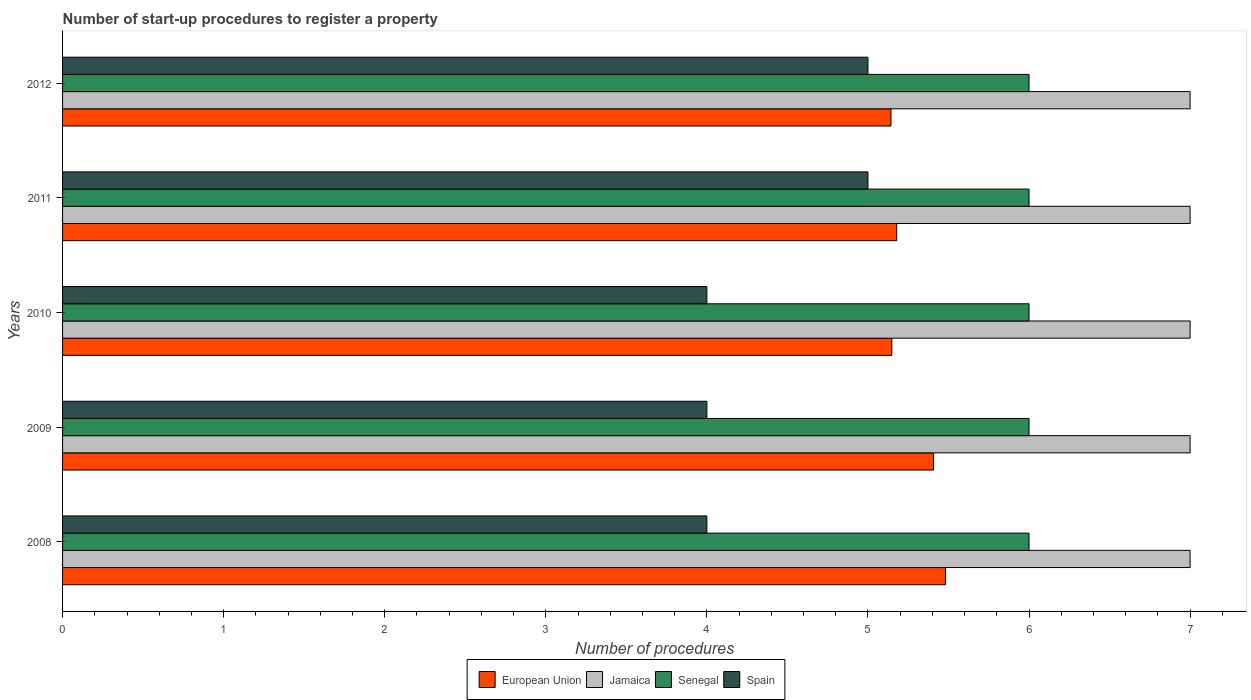How many different coloured bars are there?
Provide a succinct answer. 4. How many groups of bars are there?
Make the answer very short. 5. Are the number of bars on each tick of the Y-axis equal?
Make the answer very short. Yes. How many bars are there on the 2nd tick from the top?
Provide a succinct answer. 4. What is the label of the 2nd group of bars from the top?
Your response must be concise. 2011. In how many cases, is the number of bars for a given year not equal to the number of legend labels?
Make the answer very short. 0. What is the number of procedures required to register a property in Jamaica in 2011?
Offer a terse response. 7. Across all years, what is the maximum number of procedures required to register a property in European Union?
Your answer should be compact. 5.48. Across all years, what is the minimum number of procedures required to register a property in European Union?
Your answer should be compact. 5.14. In which year was the number of procedures required to register a property in Spain minimum?
Keep it short and to the point. 2008. What is the total number of procedures required to register a property in Senegal in the graph?
Provide a short and direct response. 30. What is the difference between the number of procedures required to register a property in Jamaica in 2010 and the number of procedures required to register a property in Spain in 2008?
Provide a short and direct response. 3. In the year 2010, what is the difference between the number of procedures required to register a property in Spain and number of procedures required to register a property in Senegal?
Ensure brevity in your answer.  -2. In how many years, is the number of procedures required to register a property in Spain greater than 1.6 ?
Provide a succinct answer. 5. What is the difference between the highest and the second highest number of procedures required to register a property in European Union?
Offer a terse response. 0.07. What is the difference between the highest and the lowest number of procedures required to register a property in Jamaica?
Offer a very short reply. 0. Is the sum of the number of procedures required to register a property in Spain in 2010 and 2012 greater than the maximum number of procedures required to register a property in European Union across all years?
Give a very brief answer. Yes. What does the 2nd bar from the top in 2011 represents?
Ensure brevity in your answer.  Senegal. What does the 3rd bar from the bottom in 2012 represents?
Offer a terse response. Senegal. Is it the case that in every year, the sum of the number of procedures required to register a property in Jamaica and number of procedures required to register a property in Spain is greater than the number of procedures required to register a property in Senegal?
Make the answer very short. Yes. How many bars are there?
Provide a succinct answer. 20. How many years are there in the graph?
Offer a very short reply. 5. Does the graph contain grids?
Provide a succinct answer. No. Where does the legend appear in the graph?
Offer a very short reply. Bottom center. How many legend labels are there?
Provide a succinct answer. 4. How are the legend labels stacked?
Offer a very short reply. Horizontal. What is the title of the graph?
Your response must be concise. Number of start-up procedures to register a property. Does "Congo (Democratic)" appear as one of the legend labels in the graph?
Provide a succinct answer. No. What is the label or title of the X-axis?
Your response must be concise. Number of procedures. What is the Number of procedures of European Union in 2008?
Offer a terse response. 5.48. What is the Number of procedures of European Union in 2009?
Give a very brief answer. 5.41. What is the Number of procedures of Jamaica in 2009?
Provide a short and direct response. 7. What is the Number of procedures of Senegal in 2009?
Give a very brief answer. 6. What is the Number of procedures in European Union in 2010?
Your response must be concise. 5.15. What is the Number of procedures of Jamaica in 2010?
Your answer should be very brief. 7. What is the Number of procedures in Spain in 2010?
Provide a succinct answer. 4. What is the Number of procedures of European Union in 2011?
Provide a succinct answer. 5.18. What is the Number of procedures of Jamaica in 2011?
Provide a short and direct response. 7. What is the Number of procedures in Senegal in 2011?
Provide a short and direct response. 6. What is the Number of procedures in Spain in 2011?
Make the answer very short. 5. What is the Number of procedures of European Union in 2012?
Offer a very short reply. 5.14. What is the Number of procedures in Jamaica in 2012?
Your response must be concise. 7. What is the Number of procedures in Senegal in 2012?
Keep it short and to the point. 6. Across all years, what is the maximum Number of procedures of European Union?
Your answer should be compact. 5.48. Across all years, what is the maximum Number of procedures of Jamaica?
Keep it short and to the point. 7. Across all years, what is the maximum Number of procedures of Spain?
Your answer should be very brief. 5. Across all years, what is the minimum Number of procedures of European Union?
Ensure brevity in your answer.  5.14. Across all years, what is the minimum Number of procedures in Jamaica?
Keep it short and to the point. 7. Across all years, what is the minimum Number of procedures in Senegal?
Offer a terse response. 6. What is the total Number of procedures in European Union in the graph?
Provide a succinct answer. 26.36. What is the total Number of procedures of Senegal in the graph?
Provide a short and direct response. 30. What is the difference between the Number of procedures in European Union in 2008 and that in 2009?
Your answer should be very brief. 0.07. What is the difference between the Number of procedures in Spain in 2008 and that in 2009?
Provide a short and direct response. 0. What is the difference between the Number of procedures of European Union in 2008 and that in 2010?
Make the answer very short. 0.33. What is the difference between the Number of procedures of Senegal in 2008 and that in 2010?
Keep it short and to the point. 0. What is the difference between the Number of procedures in Spain in 2008 and that in 2010?
Offer a terse response. 0. What is the difference between the Number of procedures in European Union in 2008 and that in 2011?
Offer a very short reply. 0.3. What is the difference between the Number of procedures in Senegal in 2008 and that in 2011?
Keep it short and to the point. 0. What is the difference between the Number of procedures in European Union in 2008 and that in 2012?
Your answer should be compact. 0.34. What is the difference between the Number of procedures of Jamaica in 2008 and that in 2012?
Provide a short and direct response. 0. What is the difference between the Number of procedures in European Union in 2009 and that in 2010?
Offer a very short reply. 0.26. What is the difference between the Number of procedures in European Union in 2009 and that in 2011?
Provide a succinct answer. 0.23. What is the difference between the Number of procedures in European Union in 2009 and that in 2012?
Your answer should be compact. 0.26. What is the difference between the Number of procedures of European Union in 2010 and that in 2011?
Provide a succinct answer. -0.03. What is the difference between the Number of procedures in Senegal in 2010 and that in 2011?
Your answer should be very brief. 0. What is the difference between the Number of procedures of European Union in 2010 and that in 2012?
Ensure brevity in your answer.  0.01. What is the difference between the Number of procedures in Spain in 2010 and that in 2012?
Your answer should be very brief. -1. What is the difference between the Number of procedures in European Union in 2011 and that in 2012?
Provide a succinct answer. 0.04. What is the difference between the Number of procedures of Senegal in 2011 and that in 2012?
Offer a terse response. 0. What is the difference between the Number of procedures in European Union in 2008 and the Number of procedures in Jamaica in 2009?
Your answer should be compact. -1.52. What is the difference between the Number of procedures in European Union in 2008 and the Number of procedures in Senegal in 2009?
Offer a terse response. -0.52. What is the difference between the Number of procedures in European Union in 2008 and the Number of procedures in Spain in 2009?
Your answer should be compact. 1.48. What is the difference between the Number of procedures in Jamaica in 2008 and the Number of procedures in Senegal in 2009?
Make the answer very short. 1. What is the difference between the Number of procedures in Jamaica in 2008 and the Number of procedures in Spain in 2009?
Your answer should be very brief. 3. What is the difference between the Number of procedures in European Union in 2008 and the Number of procedures in Jamaica in 2010?
Make the answer very short. -1.52. What is the difference between the Number of procedures in European Union in 2008 and the Number of procedures in Senegal in 2010?
Your response must be concise. -0.52. What is the difference between the Number of procedures in European Union in 2008 and the Number of procedures in Spain in 2010?
Keep it short and to the point. 1.48. What is the difference between the Number of procedures in European Union in 2008 and the Number of procedures in Jamaica in 2011?
Your response must be concise. -1.52. What is the difference between the Number of procedures in European Union in 2008 and the Number of procedures in Senegal in 2011?
Your answer should be compact. -0.52. What is the difference between the Number of procedures of European Union in 2008 and the Number of procedures of Spain in 2011?
Your answer should be very brief. 0.48. What is the difference between the Number of procedures in Jamaica in 2008 and the Number of procedures in Senegal in 2011?
Give a very brief answer. 1. What is the difference between the Number of procedures of Jamaica in 2008 and the Number of procedures of Spain in 2011?
Provide a short and direct response. 2. What is the difference between the Number of procedures in European Union in 2008 and the Number of procedures in Jamaica in 2012?
Provide a succinct answer. -1.52. What is the difference between the Number of procedures of European Union in 2008 and the Number of procedures of Senegal in 2012?
Offer a terse response. -0.52. What is the difference between the Number of procedures of European Union in 2008 and the Number of procedures of Spain in 2012?
Ensure brevity in your answer.  0.48. What is the difference between the Number of procedures of Jamaica in 2008 and the Number of procedures of Senegal in 2012?
Provide a succinct answer. 1. What is the difference between the Number of procedures in European Union in 2009 and the Number of procedures in Jamaica in 2010?
Give a very brief answer. -1.59. What is the difference between the Number of procedures of European Union in 2009 and the Number of procedures of Senegal in 2010?
Your response must be concise. -0.59. What is the difference between the Number of procedures in European Union in 2009 and the Number of procedures in Spain in 2010?
Give a very brief answer. 1.41. What is the difference between the Number of procedures in Jamaica in 2009 and the Number of procedures in Senegal in 2010?
Offer a terse response. 1. What is the difference between the Number of procedures in Jamaica in 2009 and the Number of procedures in Spain in 2010?
Your response must be concise. 3. What is the difference between the Number of procedures of European Union in 2009 and the Number of procedures of Jamaica in 2011?
Make the answer very short. -1.59. What is the difference between the Number of procedures of European Union in 2009 and the Number of procedures of Senegal in 2011?
Give a very brief answer. -0.59. What is the difference between the Number of procedures in European Union in 2009 and the Number of procedures in Spain in 2011?
Your answer should be very brief. 0.41. What is the difference between the Number of procedures in Jamaica in 2009 and the Number of procedures in Spain in 2011?
Your answer should be very brief. 2. What is the difference between the Number of procedures of European Union in 2009 and the Number of procedures of Jamaica in 2012?
Provide a short and direct response. -1.59. What is the difference between the Number of procedures of European Union in 2009 and the Number of procedures of Senegal in 2012?
Offer a very short reply. -0.59. What is the difference between the Number of procedures in European Union in 2009 and the Number of procedures in Spain in 2012?
Offer a terse response. 0.41. What is the difference between the Number of procedures in Jamaica in 2009 and the Number of procedures in Senegal in 2012?
Provide a short and direct response. 1. What is the difference between the Number of procedures in Senegal in 2009 and the Number of procedures in Spain in 2012?
Offer a very short reply. 1. What is the difference between the Number of procedures in European Union in 2010 and the Number of procedures in Jamaica in 2011?
Your response must be concise. -1.85. What is the difference between the Number of procedures in European Union in 2010 and the Number of procedures in Senegal in 2011?
Ensure brevity in your answer.  -0.85. What is the difference between the Number of procedures in European Union in 2010 and the Number of procedures in Spain in 2011?
Make the answer very short. 0.15. What is the difference between the Number of procedures of Jamaica in 2010 and the Number of procedures of Senegal in 2011?
Your response must be concise. 1. What is the difference between the Number of procedures of Jamaica in 2010 and the Number of procedures of Spain in 2011?
Offer a very short reply. 2. What is the difference between the Number of procedures of Senegal in 2010 and the Number of procedures of Spain in 2011?
Provide a succinct answer. 1. What is the difference between the Number of procedures in European Union in 2010 and the Number of procedures in Jamaica in 2012?
Provide a short and direct response. -1.85. What is the difference between the Number of procedures in European Union in 2010 and the Number of procedures in Senegal in 2012?
Your answer should be very brief. -0.85. What is the difference between the Number of procedures of European Union in 2010 and the Number of procedures of Spain in 2012?
Keep it short and to the point. 0.15. What is the difference between the Number of procedures in Jamaica in 2010 and the Number of procedures in Spain in 2012?
Give a very brief answer. 2. What is the difference between the Number of procedures of Senegal in 2010 and the Number of procedures of Spain in 2012?
Offer a terse response. 1. What is the difference between the Number of procedures in European Union in 2011 and the Number of procedures in Jamaica in 2012?
Offer a very short reply. -1.82. What is the difference between the Number of procedures of European Union in 2011 and the Number of procedures of Senegal in 2012?
Provide a succinct answer. -0.82. What is the difference between the Number of procedures in European Union in 2011 and the Number of procedures in Spain in 2012?
Make the answer very short. 0.18. What is the difference between the Number of procedures of Senegal in 2011 and the Number of procedures of Spain in 2012?
Provide a short and direct response. 1. What is the average Number of procedures in European Union per year?
Your answer should be compact. 5.27. In the year 2008, what is the difference between the Number of procedures in European Union and Number of procedures in Jamaica?
Your response must be concise. -1.52. In the year 2008, what is the difference between the Number of procedures in European Union and Number of procedures in Senegal?
Ensure brevity in your answer.  -0.52. In the year 2008, what is the difference between the Number of procedures of European Union and Number of procedures of Spain?
Make the answer very short. 1.48. In the year 2008, what is the difference between the Number of procedures in Jamaica and Number of procedures in Senegal?
Give a very brief answer. 1. In the year 2008, what is the difference between the Number of procedures in Jamaica and Number of procedures in Spain?
Your response must be concise. 3. In the year 2009, what is the difference between the Number of procedures in European Union and Number of procedures in Jamaica?
Your answer should be compact. -1.59. In the year 2009, what is the difference between the Number of procedures in European Union and Number of procedures in Senegal?
Give a very brief answer. -0.59. In the year 2009, what is the difference between the Number of procedures of European Union and Number of procedures of Spain?
Provide a succinct answer. 1.41. In the year 2009, what is the difference between the Number of procedures in Jamaica and Number of procedures in Spain?
Your answer should be very brief. 3. In the year 2010, what is the difference between the Number of procedures in European Union and Number of procedures in Jamaica?
Give a very brief answer. -1.85. In the year 2010, what is the difference between the Number of procedures in European Union and Number of procedures in Senegal?
Offer a terse response. -0.85. In the year 2010, what is the difference between the Number of procedures of European Union and Number of procedures of Spain?
Keep it short and to the point. 1.15. In the year 2010, what is the difference between the Number of procedures in Jamaica and Number of procedures in Senegal?
Keep it short and to the point. 1. In the year 2010, what is the difference between the Number of procedures of Jamaica and Number of procedures of Spain?
Your answer should be compact. 3. In the year 2010, what is the difference between the Number of procedures in Senegal and Number of procedures in Spain?
Your answer should be compact. 2. In the year 2011, what is the difference between the Number of procedures in European Union and Number of procedures in Jamaica?
Give a very brief answer. -1.82. In the year 2011, what is the difference between the Number of procedures in European Union and Number of procedures in Senegal?
Your response must be concise. -0.82. In the year 2011, what is the difference between the Number of procedures of European Union and Number of procedures of Spain?
Offer a terse response. 0.18. In the year 2012, what is the difference between the Number of procedures of European Union and Number of procedures of Jamaica?
Give a very brief answer. -1.86. In the year 2012, what is the difference between the Number of procedures in European Union and Number of procedures in Senegal?
Your answer should be very brief. -0.86. In the year 2012, what is the difference between the Number of procedures of European Union and Number of procedures of Spain?
Make the answer very short. 0.14. In the year 2012, what is the difference between the Number of procedures in Jamaica and Number of procedures in Senegal?
Your answer should be compact. 1. In the year 2012, what is the difference between the Number of procedures of Jamaica and Number of procedures of Spain?
Ensure brevity in your answer.  2. What is the ratio of the Number of procedures in European Union in 2008 to that in 2009?
Your response must be concise. 1.01. What is the ratio of the Number of procedures of European Union in 2008 to that in 2010?
Your response must be concise. 1.06. What is the ratio of the Number of procedures in Jamaica in 2008 to that in 2010?
Make the answer very short. 1. What is the ratio of the Number of procedures of European Union in 2008 to that in 2011?
Your answer should be compact. 1.06. What is the ratio of the Number of procedures of Jamaica in 2008 to that in 2011?
Provide a succinct answer. 1. What is the ratio of the Number of procedures in Senegal in 2008 to that in 2011?
Make the answer very short. 1. What is the ratio of the Number of procedures in Spain in 2008 to that in 2011?
Your answer should be compact. 0.8. What is the ratio of the Number of procedures in European Union in 2008 to that in 2012?
Give a very brief answer. 1.07. What is the ratio of the Number of procedures of Jamaica in 2008 to that in 2012?
Offer a terse response. 1. What is the ratio of the Number of procedures of European Union in 2009 to that in 2010?
Keep it short and to the point. 1.05. What is the ratio of the Number of procedures in Senegal in 2009 to that in 2010?
Ensure brevity in your answer.  1. What is the ratio of the Number of procedures in European Union in 2009 to that in 2011?
Offer a terse response. 1.04. What is the ratio of the Number of procedures in Senegal in 2009 to that in 2011?
Make the answer very short. 1. What is the ratio of the Number of procedures of Spain in 2009 to that in 2011?
Offer a very short reply. 0.8. What is the ratio of the Number of procedures of European Union in 2009 to that in 2012?
Offer a terse response. 1.05. What is the ratio of the Number of procedures in European Union in 2010 to that in 2012?
Make the answer very short. 1. What is the ratio of the Number of procedures of European Union in 2011 to that in 2012?
Your answer should be very brief. 1.01. What is the ratio of the Number of procedures in Jamaica in 2011 to that in 2012?
Provide a short and direct response. 1. What is the ratio of the Number of procedures in Senegal in 2011 to that in 2012?
Your answer should be compact. 1. What is the difference between the highest and the second highest Number of procedures in European Union?
Give a very brief answer. 0.07. What is the difference between the highest and the lowest Number of procedures of European Union?
Make the answer very short. 0.34. What is the difference between the highest and the lowest Number of procedures in Senegal?
Ensure brevity in your answer.  0. What is the difference between the highest and the lowest Number of procedures of Spain?
Ensure brevity in your answer.  1. 